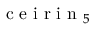<formula> <loc_0><loc_0><loc_500><loc_500>{ c e i r i n } _ { 5 }</formula> 